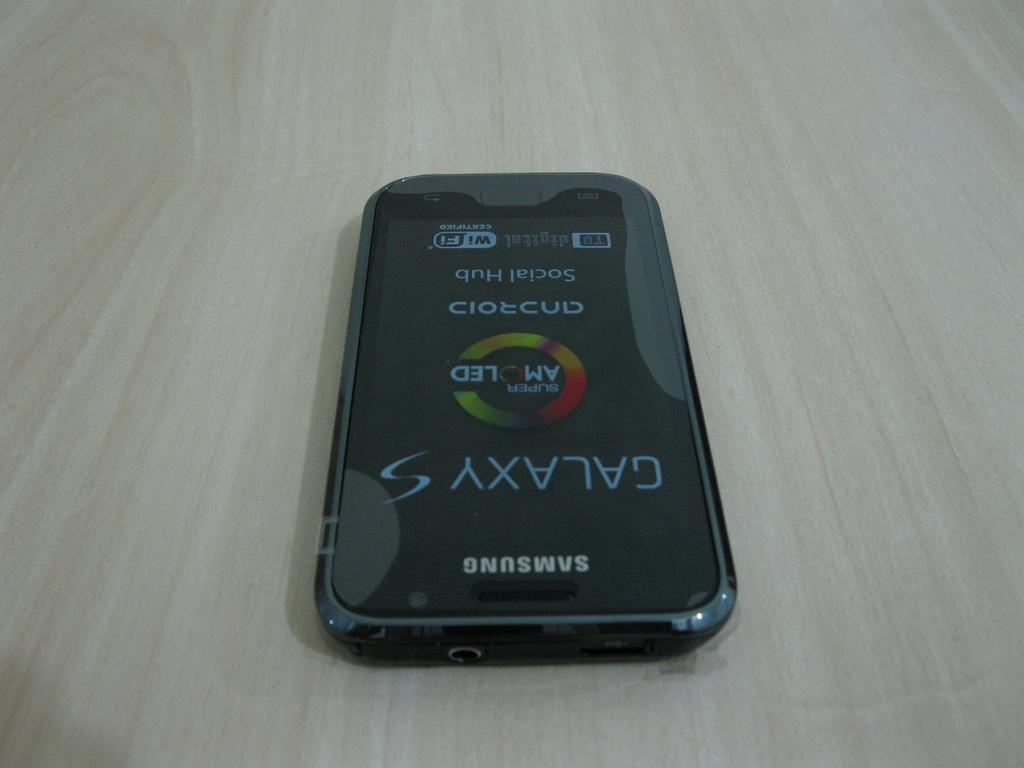<image>
Render a clear and concise summary of the photo. A Samsung Galaxy phone with a Super AMOLED display sits on a wooden table. 